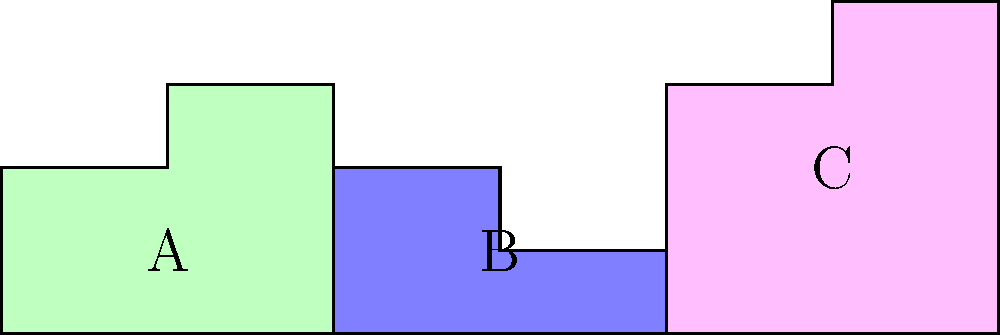In a study on land distribution inequality, three regions (A, B, and C) are represented by irregular shapes on a grid where each unit represents 1 square kilometer. Calculate the total area of these regions and determine what percentage of the total area is occupied by the largest region. How might this visual representation be used to discuss wealth concentration in your sociological speeches? To solve this problem, we'll follow these steps:

1. Calculate the area of each region:

Region A (green):
$$ A_A = 4 \times 2 + 2 \times 1 = 10 \text{ km}^2 $$

Region B (blue):
$$ A_B = 4 \times 1 + 2 \times 1 = 6 \text{ km}^2 $$

Region C (pink):
$$ A_C = 4 \times 3 + 2 \times 1 = 14 \text{ km}^2 $$

2. Calculate the total area:
$$ A_{total} = A_A + A_B + A_C = 10 + 6 + 14 = 30 \text{ km}^2 $$

3. Identify the largest region:
Region C with 14 km^2 is the largest.

4. Calculate the percentage of the total area occupied by the largest region:
$$ \text{Percentage} = \frac{A_C}{A_{total}} \times 100\% = \frac{14}{30} \times 100\% \approx 46.67\% $$

This visual representation can be used in sociological speeches to illustrate wealth concentration by comparing land distribution to wealth distribution. The irregular shapes and unequal sizes of the regions can represent how wealth is unevenly distributed in society. The fact that the largest region (C) occupies nearly half of the total area could be analogous to how a small percentage of the population often controls a disproportionately large share of wealth in many societies.
Answer: Total area: 30 km^2; Largest region percentage: 46.67% 